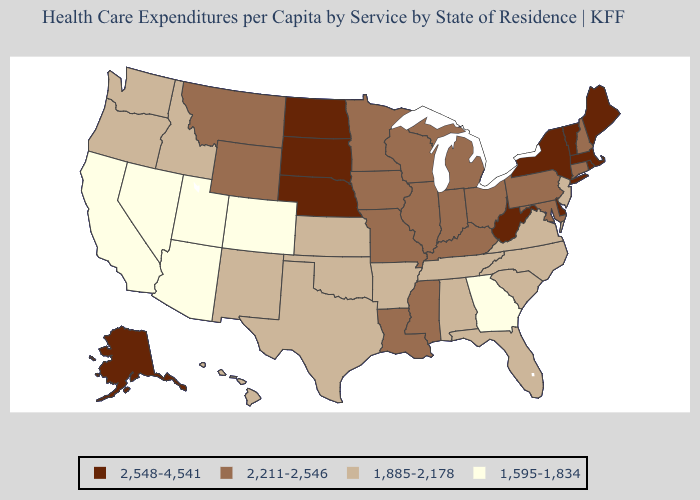What is the lowest value in states that border Colorado?
Short answer required. 1,595-1,834. What is the lowest value in the MidWest?
Answer briefly. 1,885-2,178. Does Utah have the lowest value in the West?
Answer briefly. Yes. Name the states that have a value in the range 1,885-2,178?
Short answer required. Alabama, Arkansas, Florida, Hawaii, Idaho, Kansas, New Jersey, New Mexico, North Carolina, Oklahoma, Oregon, South Carolina, Tennessee, Texas, Virginia, Washington. Does Delaware have the same value as Florida?
Concise answer only. No. What is the value of Delaware?
Short answer required. 2,548-4,541. Name the states that have a value in the range 1,885-2,178?
Short answer required. Alabama, Arkansas, Florida, Hawaii, Idaho, Kansas, New Jersey, New Mexico, North Carolina, Oklahoma, Oregon, South Carolina, Tennessee, Texas, Virginia, Washington. What is the value of Oregon?
Concise answer only. 1,885-2,178. What is the value of Minnesota?
Be succinct. 2,211-2,546. Name the states that have a value in the range 1,885-2,178?
Be succinct. Alabama, Arkansas, Florida, Hawaii, Idaho, Kansas, New Jersey, New Mexico, North Carolina, Oklahoma, Oregon, South Carolina, Tennessee, Texas, Virginia, Washington. What is the value of Louisiana?
Quick response, please. 2,211-2,546. Does Nevada have the lowest value in the USA?
Concise answer only. Yes. How many symbols are there in the legend?
Quick response, please. 4. Name the states that have a value in the range 1,885-2,178?
Be succinct. Alabama, Arkansas, Florida, Hawaii, Idaho, Kansas, New Jersey, New Mexico, North Carolina, Oklahoma, Oregon, South Carolina, Tennessee, Texas, Virginia, Washington. Does Ohio have the highest value in the USA?
Quick response, please. No. 